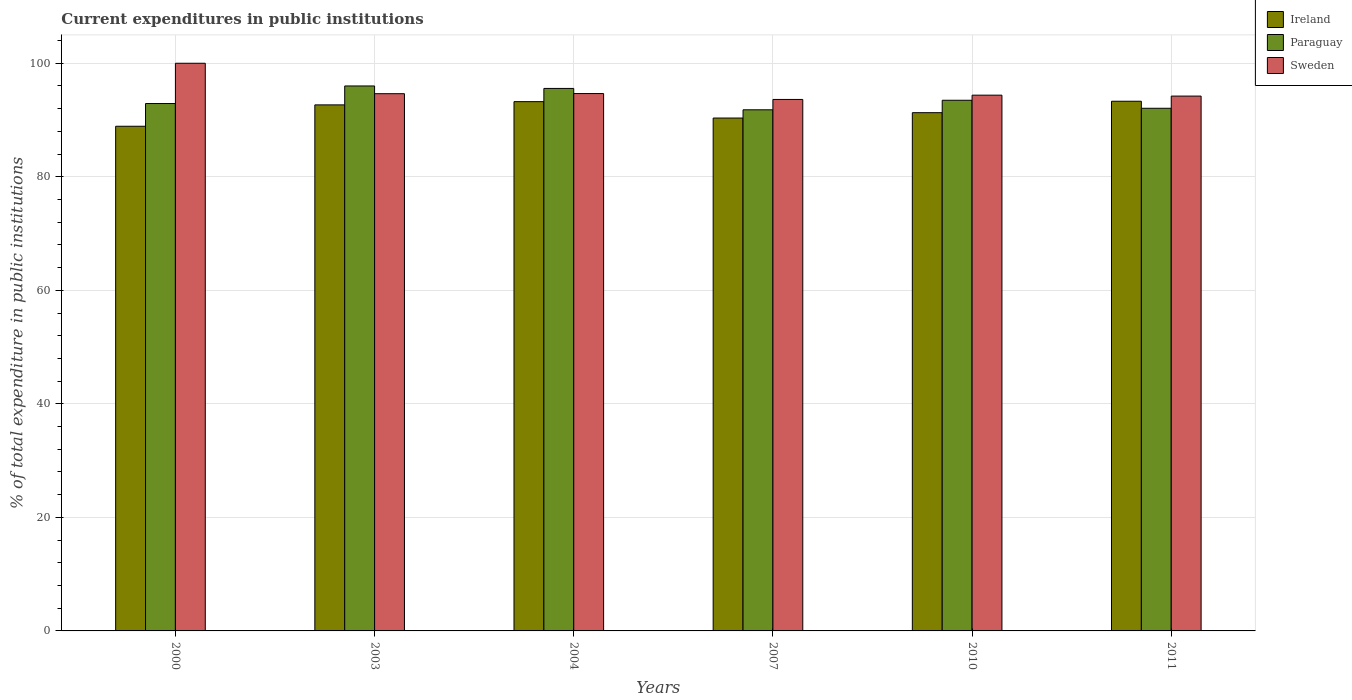Are the number of bars on each tick of the X-axis equal?
Provide a short and direct response. Yes. In how many cases, is the number of bars for a given year not equal to the number of legend labels?
Keep it short and to the point. 0. What is the current expenditures in public institutions in Paraguay in 2011?
Provide a succinct answer. 92.07. Across all years, what is the maximum current expenditures in public institutions in Paraguay?
Offer a terse response. 96. Across all years, what is the minimum current expenditures in public institutions in Sweden?
Give a very brief answer. 93.62. In which year was the current expenditures in public institutions in Sweden maximum?
Provide a short and direct response. 2000. What is the total current expenditures in public institutions in Paraguay in the graph?
Keep it short and to the point. 561.82. What is the difference between the current expenditures in public institutions in Paraguay in 2003 and that in 2011?
Give a very brief answer. 3.93. What is the difference between the current expenditures in public institutions in Ireland in 2007 and the current expenditures in public institutions in Sweden in 2004?
Make the answer very short. -4.31. What is the average current expenditures in public institutions in Ireland per year?
Keep it short and to the point. 91.63. In the year 2000, what is the difference between the current expenditures in public institutions in Sweden and current expenditures in public institutions in Ireland?
Make the answer very short. 11.1. In how many years, is the current expenditures in public institutions in Ireland greater than 56 %?
Give a very brief answer. 6. What is the ratio of the current expenditures in public institutions in Paraguay in 2004 to that in 2011?
Keep it short and to the point. 1.04. What is the difference between the highest and the second highest current expenditures in public institutions in Ireland?
Ensure brevity in your answer.  0.07. What is the difference between the highest and the lowest current expenditures in public institutions in Paraguay?
Offer a terse response. 4.2. In how many years, is the current expenditures in public institutions in Sweden greater than the average current expenditures in public institutions in Sweden taken over all years?
Provide a short and direct response. 1. Is the sum of the current expenditures in public institutions in Paraguay in 2000 and 2011 greater than the maximum current expenditures in public institutions in Ireland across all years?
Keep it short and to the point. Yes. What does the 3rd bar from the left in 2007 represents?
Your answer should be compact. Sweden. What does the 1st bar from the right in 2011 represents?
Your answer should be compact. Sweden. Is it the case that in every year, the sum of the current expenditures in public institutions in Ireland and current expenditures in public institutions in Sweden is greater than the current expenditures in public institutions in Paraguay?
Offer a terse response. Yes. Are all the bars in the graph horizontal?
Offer a terse response. No. How many years are there in the graph?
Your answer should be compact. 6. Does the graph contain any zero values?
Offer a terse response. No. Where does the legend appear in the graph?
Your answer should be compact. Top right. How are the legend labels stacked?
Ensure brevity in your answer.  Vertical. What is the title of the graph?
Provide a short and direct response. Current expenditures in public institutions. What is the label or title of the X-axis?
Give a very brief answer. Years. What is the label or title of the Y-axis?
Offer a terse response. % of total expenditure in public institutions. What is the % of total expenditure in public institutions in Ireland in 2000?
Your response must be concise. 88.9. What is the % of total expenditure in public institutions in Paraguay in 2000?
Offer a very short reply. 92.9. What is the % of total expenditure in public institutions in Ireland in 2003?
Ensure brevity in your answer.  92.67. What is the % of total expenditure in public institutions of Paraguay in 2003?
Offer a terse response. 96. What is the % of total expenditure in public institutions in Sweden in 2003?
Give a very brief answer. 94.64. What is the % of total expenditure in public institutions of Ireland in 2004?
Make the answer very short. 93.24. What is the % of total expenditure in public institutions in Paraguay in 2004?
Your answer should be very brief. 95.57. What is the % of total expenditure in public institutions of Sweden in 2004?
Your answer should be very brief. 94.66. What is the % of total expenditure in public institutions in Ireland in 2007?
Offer a terse response. 90.35. What is the % of total expenditure in public institutions of Paraguay in 2007?
Keep it short and to the point. 91.8. What is the % of total expenditure in public institutions of Sweden in 2007?
Make the answer very short. 93.62. What is the % of total expenditure in public institutions of Ireland in 2010?
Offer a very short reply. 91.29. What is the % of total expenditure in public institutions in Paraguay in 2010?
Make the answer very short. 93.48. What is the % of total expenditure in public institutions of Sweden in 2010?
Your response must be concise. 94.38. What is the % of total expenditure in public institutions in Ireland in 2011?
Offer a terse response. 93.31. What is the % of total expenditure in public institutions in Paraguay in 2011?
Keep it short and to the point. 92.07. What is the % of total expenditure in public institutions in Sweden in 2011?
Make the answer very short. 94.22. Across all years, what is the maximum % of total expenditure in public institutions of Ireland?
Offer a terse response. 93.31. Across all years, what is the maximum % of total expenditure in public institutions of Paraguay?
Offer a very short reply. 96. Across all years, what is the maximum % of total expenditure in public institutions in Sweden?
Provide a short and direct response. 100. Across all years, what is the minimum % of total expenditure in public institutions in Ireland?
Provide a succinct answer. 88.9. Across all years, what is the minimum % of total expenditure in public institutions of Paraguay?
Ensure brevity in your answer.  91.8. Across all years, what is the minimum % of total expenditure in public institutions in Sweden?
Offer a very short reply. 93.62. What is the total % of total expenditure in public institutions of Ireland in the graph?
Your answer should be very brief. 549.76. What is the total % of total expenditure in public institutions of Paraguay in the graph?
Keep it short and to the point. 561.83. What is the total % of total expenditure in public institutions of Sweden in the graph?
Your answer should be compact. 571.52. What is the difference between the % of total expenditure in public institutions in Ireland in 2000 and that in 2003?
Your response must be concise. -3.77. What is the difference between the % of total expenditure in public institutions in Paraguay in 2000 and that in 2003?
Offer a terse response. -3.1. What is the difference between the % of total expenditure in public institutions of Sweden in 2000 and that in 2003?
Keep it short and to the point. 5.36. What is the difference between the % of total expenditure in public institutions in Ireland in 2000 and that in 2004?
Provide a succinct answer. -4.33. What is the difference between the % of total expenditure in public institutions of Paraguay in 2000 and that in 2004?
Offer a terse response. -2.66. What is the difference between the % of total expenditure in public institutions in Sweden in 2000 and that in 2004?
Offer a terse response. 5.34. What is the difference between the % of total expenditure in public institutions in Ireland in 2000 and that in 2007?
Provide a succinct answer. -1.45. What is the difference between the % of total expenditure in public institutions in Paraguay in 2000 and that in 2007?
Give a very brief answer. 1.1. What is the difference between the % of total expenditure in public institutions in Sweden in 2000 and that in 2007?
Keep it short and to the point. 6.38. What is the difference between the % of total expenditure in public institutions of Ireland in 2000 and that in 2010?
Ensure brevity in your answer.  -2.39. What is the difference between the % of total expenditure in public institutions in Paraguay in 2000 and that in 2010?
Your response must be concise. -0.58. What is the difference between the % of total expenditure in public institutions in Sweden in 2000 and that in 2010?
Provide a short and direct response. 5.62. What is the difference between the % of total expenditure in public institutions of Ireland in 2000 and that in 2011?
Provide a short and direct response. -4.41. What is the difference between the % of total expenditure in public institutions in Paraguay in 2000 and that in 2011?
Provide a succinct answer. 0.83. What is the difference between the % of total expenditure in public institutions of Sweden in 2000 and that in 2011?
Make the answer very short. 5.78. What is the difference between the % of total expenditure in public institutions of Ireland in 2003 and that in 2004?
Offer a very short reply. -0.57. What is the difference between the % of total expenditure in public institutions in Paraguay in 2003 and that in 2004?
Ensure brevity in your answer.  0.44. What is the difference between the % of total expenditure in public institutions of Sweden in 2003 and that in 2004?
Your answer should be very brief. -0.02. What is the difference between the % of total expenditure in public institutions in Ireland in 2003 and that in 2007?
Your answer should be very brief. 2.32. What is the difference between the % of total expenditure in public institutions of Paraguay in 2003 and that in 2007?
Provide a short and direct response. 4.2. What is the difference between the % of total expenditure in public institutions in Sweden in 2003 and that in 2007?
Your answer should be compact. 1.02. What is the difference between the % of total expenditure in public institutions of Ireland in 2003 and that in 2010?
Your answer should be very brief. 1.37. What is the difference between the % of total expenditure in public institutions of Paraguay in 2003 and that in 2010?
Offer a terse response. 2.52. What is the difference between the % of total expenditure in public institutions in Sweden in 2003 and that in 2010?
Give a very brief answer. 0.26. What is the difference between the % of total expenditure in public institutions in Ireland in 2003 and that in 2011?
Your response must be concise. -0.64. What is the difference between the % of total expenditure in public institutions of Paraguay in 2003 and that in 2011?
Your response must be concise. 3.93. What is the difference between the % of total expenditure in public institutions in Sweden in 2003 and that in 2011?
Offer a very short reply. 0.42. What is the difference between the % of total expenditure in public institutions in Ireland in 2004 and that in 2007?
Make the answer very short. 2.89. What is the difference between the % of total expenditure in public institutions of Paraguay in 2004 and that in 2007?
Your answer should be compact. 3.76. What is the difference between the % of total expenditure in public institutions of Sweden in 2004 and that in 2007?
Your answer should be compact. 1.04. What is the difference between the % of total expenditure in public institutions of Ireland in 2004 and that in 2010?
Provide a succinct answer. 1.94. What is the difference between the % of total expenditure in public institutions in Paraguay in 2004 and that in 2010?
Provide a short and direct response. 2.08. What is the difference between the % of total expenditure in public institutions in Sweden in 2004 and that in 2010?
Your response must be concise. 0.28. What is the difference between the % of total expenditure in public institutions in Ireland in 2004 and that in 2011?
Keep it short and to the point. -0.07. What is the difference between the % of total expenditure in public institutions in Paraguay in 2004 and that in 2011?
Give a very brief answer. 3.49. What is the difference between the % of total expenditure in public institutions in Sweden in 2004 and that in 2011?
Your answer should be compact. 0.44. What is the difference between the % of total expenditure in public institutions in Ireland in 2007 and that in 2010?
Keep it short and to the point. -0.94. What is the difference between the % of total expenditure in public institutions of Paraguay in 2007 and that in 2010?
Make the answer very short. -1.68. What is the difference between the % of total expenditure in public institutions in Sweden in 2007 and that in 2010?
Your response must be concise. -0.76. What is the difference between the % of total expenditure in public institutions of Ireland in 2007 and that in 2011?
Provide a short and direct response. -2.96. What is the difference between the % of total expenditure in public institutions in Paraguay in 2007 and that in 2011?
Provide a succinct answer. -0.27. What is the difference between the % of total expenditure in public institutions of Sweden in 2007 and that in 2011?
Your response must be concise. -0.59. What is the difference between the % of total expenditure in public institutions in Ireland in 2010 and that in 2011?
Provide a short and direct response. -2.01. What is the difference between the % of total expenditure in public institutions in Paraguay in 2010 and that in 2011?
Your answer should be compact. 1.41. What is the difference between the % of total expenditure in public institutions in Sweden in 2010 and that in 2011?
Ensure brevity in your answer.  0.16. What is the difference between the % of total expenditure in public institutions in Ireland in 2000 and the % of total expenditure in public institutions in Paraguay in 2003?
Ensure brevity in your answer.  -7.1. What is the difference between the % of total expenditure in public institutions in Ireland in 2000 and the % of total expenditure in public institutions in Sweden in 2003?
Provide a succinct answer. -5.74. What is the difference between the % of total expenditure in public institutions in Paraguay in 2000 and the % of total expenditure in public institutions in Sweden in 2003?
Make the answer very short. -1.73. What is the difference between the % of total expenditure in public institutions in Ireland in 2000 and the % of total expenditure in public institutions in Paraguay in 2004?
Provide a short and direct response. -6.66. What is the difference between the % of total expenditure in public institutions of Ireland in 2000 and the % of total expenditure in public institutions of Sweden in 2004?
Your response must be concise. -5.76. What is the difference between the % of total expenditure in public institutions in Paraguay in 2000 and the % of total expenditure in public institutions in Sweden in 2004?
Your answer should be very brief. -1.76. What is the difference between the % of total expenditure in public institutions in Ireland in 2000 and the % of total expenditure in public institutions in Paraguay in 2007?
Provide a succinct answer. -2.9. What is the difference between the % of total expenditure in public institutions of Ireland in 2000 and the % of total expenditure in public institutions of Sweden in 2007?
Provide a short and direct response. -4.72. What is the difference between the % of total expenditure in public institutions in Paraguay in 2000 and the % of total expenditure in public institutions in Sweden in 2007?
Your response must be concise. -0.72. What is the difference between the % of total expenditure in public institutions in Ireland in 2000 and the % of total expenditure in public institutions in Paraguay in 2010?
Your response must be concise. -4.58. What is the difference between the % of total expenditure in public institutions in Ireland in 2000 and the % of total expenditure in public institutions in Sweden in 2010?
Your answer should be very brief. -5.48. What is the difference between the % of total expenditure in public institutions of Paraguay in 2000 and the % of total expenditure in public institutions of Sweden in 2010?
Your answer should be very brief. -1.47. What is the difference between the % of total expenditure in public institutions in Ireland in 2000 and the % of total expenditure in public institutions in Paraguay in 2011?
Provide a short and direct response. -3.17. What is the difference between the % of total expenditure in public institutions in Ireland in 2000 and the % of total expenditure in public institutions in Sweden in 2011?
Provide a short and direct response. -5.32. What is the difference between the % of total expenditure in public institutions in Paraguay in 2000 and the % of total expenditure in public institutions in Sweden in 2011?
Give a very brief answer. -1.31. What is the difference between the % of total expenditure in public institutions of Ireland in 2003 and the % of total expenditure in public institutions of Paraguay in 2004?
Offer a very short reply. -2.9. What is the difference between the % of total expenditure in public institutions of Ireland in 2003 and the % of total expenditure in public institutions of Sweden in 2004?
Ensure brevity in your answer.  -2. What is the difference between the % of total expenditure in public institutions in Paraguay in 2003 and the % of total expenditure in public institutions in Sweden in 2004?
Your answer should be very brief. 1.34. What is the difference between the % of total expenditure in public institutions in Ireland in 2003 and the % of total expenditure in public institutions in Paraguay in 2007?
Give a very brief answer. 0.87. What is the difference between the % of total expenditure in public institutions in Ireland in 2003 and the % of total expenditure in public institutions in Sweden in 2007?
Offer a very short reply. -0.96. What is the difference between the % of total expenditure in public institutions of Paraguay in 2003 and the % of total expenditure in public institutions of Sweden in 2007?
Your answer should be compact. 2.38. What is the difference between the % of total expenditure in public institutions in Ireland in 2003 and the % of total expenditure in public institutions in Paraguay in 2010?
Provide a short and direct response. -0.82. What is the difference between the % of total expenditure in public institutions in Ireland in 2003 and the % of total expenditure in public institutions in Sweden in 2010?
Ensure brevity in your answer.  -1.71. What is the difference between the % of total expenditure in public institutions of Paraguay in 2003 and the % of total expenditure in public institutions of Sweden in 2010?
Give a very brief answer. 1.62. What is the difference between the % of total expenditure in public institutions in Ireland in 2003 and the % of total expenditure in public institutions in Paraguay in 2011?
Offer a terse response. 0.6. What is the difference between the % of total expenditure in public institutions in Ireland in 2003 and the % of total expenditure in public institutions in Sweden in 2011?
Make the answer very short. -1.55. What is the difference between the % of total expenditure in public institutions in Paraguay in 2003 and the % of total expenditure in public institutions in Sweden in 2011?
Provide a succinct answer. 1.78. What is the difference between the % of total expenditure in public institutions of Ireland in 2004 and the % of total expenditure in public institutions of Paraguay in 2007?
Give a very brief answer. 1.44. What is the difference between the % of total expenditure in public institutions of Ireland in 2004 and the % of total expenditure in public institutions of Sweden in 2007?
Offer a terse response. -0.39. What is the difference between the % of total expenditure in public institutions in Paraguay in 2004 and the % of total expenditure in public institutions in Sweden in 2007?
Make the answer very short. 1.94. What is the difference between the % of total expenditure in public institutions in Ireland in 2004 and the % of total expenditure in public institutions in Paraguay in 2010?
Make the answer very short. -0.25. What is the difference between the % of total expenditure in public institutions of Ireland in 2004 and the % of total expenditure in public institutions of Sweden in 2010?
Your response must be concise. -1.14. What is the difference between the % of total expenditure in public institutions in Paraguay in 2004 and the % of total expenditure in public institutions in Sweden in 2010?
Provide a succinct answer. 1.19. What is the difference between the % of total expenditure in public institutions of Ireland in 2004 and the % of total expenditure in public institutions of Paraguay in 2011?
Your answer should be very brief. 1.17. What is the difference between the % of total expenditure in public institutions in Ireland in 2004 and the % of total expenditure in public institutions in Sweden in 2011?
Your answer should be very brief. -0.98. What is the difference between the % of total expenditure in public institutions in Paraguay in 2004 and the % of total expenditure in public institutions in Sweden in 2011?
Your response must be concise. 1.35. What is the difference between the % of total expenditure in public institutions of Ireland in 2007 and the % of total expenditure in public institutions of Paraguay in 2010?
Make the answer very short. -3.13. What is the difference between the % of total expenditure in public institutions in Ireland in 2007 and the % of total expenditure in public institutions in Sweden in 2010?
Ensure brevity in your answer.  -4.03. What is the difference between the % of total expenditure in public institutions in Paraguay in 2007 and the % of total expenditure in public institutions in Sweden in 2010?
Ensure brevity in your answer.  -2.58. What is the difference between the % of total expenditure in public institutions of Ireland in 2007 and the % of total expenditure in public institutions of Paraguay in 2011?
Provide a short and direct response. -1.72. What is the difference between the % of total expenditure in public institutions in Ireland in 2007 and the % of total expenditure in public institutions in Sweden in 2011?
Provide a succinct answer. -3.87. What is the difference between the % of total expenditure in public institutions in Paraguay in 2007 and the % of total expenditure in public institutions in Sweden in 2011?
Your response must be concise. -2.42. What is the difference between the % of total expenditure in public institutions in Ireland in 2010 and the % of total expenditure in public institutions in Paraguay in 2011?
Offer a terse response. -0.78. What is the difference between the % of total expenditure in public institutions in Ireland in 2010 and the % of total expenditure in public institutions in Sweden in 2011?
Your response must be concise. -2.92. What is the difference between the % of total expenditure in public institutions in Paraguay in 2010 and the % of total expenditure in public institutions in Sweden in 2011?
Give a very brief answer. -0.73. What is the average % of total expenditure in public institutions of Ireland per year?
Make the answer very short. 91.63. What is the average % of total expenditure in public institutions of Paraguay per year?
Ensure brevity in your answer.  93.64. What is the average % of total expenditure in public institutions in Sweden per year?
Your answer should be compact. 95.25. In the year 2000, what is the difference between the % of total expenditure in public institutions in Ireland and % of total expenditure in public institutions in Paraguay?
Provide a succinct answer. -4. In the year 2000, what is the difference between the % of total expenditure in public institutions in Ireland and % of total expenditure in public institutions in Sweden?
Keep it short and to the point. -11.1. In the year 2000, what is the difference between the % of total expenditure in public institutions of Paraguay and % of total expenditure in public institutions of Sweden?
Keep it short and to the point. -7.1. In the year 2003, what is the difference between the % of total expenditure in public institutions of Ireland and % of total expenditure in public institutions of Paraguay?
Provide a short and direct response. -3.33. In the year 2003, what is the difference between the % of total expenditure in public institutions of Ireland and % of total expenditure in public institutions of Sweden?
Your answer should be compact. -1.97. In the year 2003, what is the difference between the % of total expenditure in public institutions of Paraguay and % of total expenditure in public institutions of Sweden?
Offer a very short reply. 1.36. In the year 2004, what is the difference between the % of total expenditure in public institutions in Ireland and % of total expenditure in public institutions in Paraguay?
Your response must be concise. -2.33. In the year 2004, what is the difference between the % of total expenditure in public institutions in Ireland and % of total expenditure in public institutions in Sweden?
Offer a terse response. -1.43. In the year 2004, what is the difference between the % of total expenditure in public institutions of Paraguay and % of total expenditure in public institutions of Sweden?
Provide a short and direct response. 0.9. In the year 2007, what is the difference between the % of total expenditure in public institutions of Ireland and % of total expenditure in public institutions of Paraguay?
Offer a terse response. -1.45. In the year 2007, what is the difference between the % of total expenditure in public institutions in Ireland and % of total expenditure in public institutions in Sweden?
Ensure brevity in your answer.  -3.27. In the year 2007, what is the difference between the % of total expenditure in public institutions in Paraguay and % of total expenditure in public institutions in Sweden?
Your answer should be very brief. -1.82. In the year 2010, what is the difference between the % of total expenditure in public institutions in Ireland and % of total expenditure in public institutions in Paraguay?
Provide a succinct answer. -2.19. In the year 2010, what is the difference between the % of total expenditure in public institutions in Ireland and % of total expenditure in public institutions in Sweden?
Keep it short and to the point. -3.09. In the year 2010, what is the difference between the % of total expenditure in public institutions of Paraguay and % of total expenditure in public institutions of Sweden?
Your answer should be compact. -0.9. In the year 2011, what is the difference between the % of total expenditure in public institutions in Ireland and % of total expenditure in public institutions in Paraguay?
Your answer should be compact. 1.24. In the year 2011, what is the difference between the % of total expenditure in public institutions in Ireland and % of total expenditure in public institutions in Sweden?
Your answer should be compact. -0.91. In the year 2011, what is the difference between the % of total expenditure in public institutions in Paraguay and % of total expenditure in public institutions in Sweden?
Make the answer very short. -2.15. What is the ratio of the % of total expenditure in public institutions of Ireland in 2000 to that in 2003?
Offer a terse response. 0.96. What is the ratio of the % of total expenditure in public institutions in Paraguay in 2000 to that in 2003?
Your answer should be compact. 0.97. What is the ratio of the % of total expenditure in public institutions in Sweden in 2000 to that in 2003?
Offer a terse response. 1.06. What is the ratio of the % of total expenditure in public institutions of Ireland in 2000 to that in 2004?
Give a very brief answer. 0.95. What is the ratio of the % of total expenditure in public institutions in Paraguay in 2000 to that in 2004?
Offer a very short reply. 0.97. What is the ratio of the % of total expenditure in public institutions of Sweden in 2000 to that in 2004?
Give a very brief answer. 1.06. What is the ratio of the % of total expenditure in public institutions of Paraguay in 2000 to that in 2007?
Ensure brevity in your answer.  1.01. What is the ratio of the % of total expenditure in public institutions in Sweden in 2000 to that in 2007?
Offer a terse response. 1.07. What is the ratio of the % of total expenditure in public institutions in Ireland in 2000 to that in 2010?
Offer a very short reply. 0.97. What is the ratio of the % of total expenditure in public institutions of Sweden in 2000 to that in 2010?
Ensure brevity in your answer.  1.06. What is the ratio of the % of total expenditure in public institutions in Ireland in 2000 to that in 2011?
Provide a short and direct response. 0.95. What is the ratio of the % of total expenditure in public institutions of Paraguay in 2000 to that in 2011?
Your answer should be compact. 1.01. What is the ratio of the % of total expenditure in public institutions of Sweden in 2000 to that in 2011?
Ensure brevity in your answer.  1.06. What is the ratio of the % of total expenditure in public institutions of Ireland in 2003 to that in 2007?
Offer a terse response. 1.03. What is the ratio of the % of total expenditure in public institutions in Paraguay in 2003 to that in 2007?
Ensure brevity in your answer.  1.05. What is the ratio of the % of total expenditure in public institutions in Sweden in 2003 to that in 2007?
Your response must be concise. 1.01. What is the ratio of the % of total expenditure in public institutions of Paraguay in 2003 to that in 2010?
Keep it short and to the point. 1.03. What is the ratio of the % of total expenditure in public institutions of Paraguay in 2003 to that in 2011?
Give a very brief answer. 1.04. What is the ratio of the % of total expenditure in public institutions of Sweden in 2003 to that in 2011?
Keep it short and to the point. 1. What is the ratio of the % of total expenditure in public institutions in Ireland in 2004 to that in 2007?
Provide a succinct answer. 1.03. What is the ratio of the % of total expenditure in public institutions of Paraguay in 2004 to that in 2007?
Your response must be concise. 1.04. What is the ratio of the % of total expenditure in public institutions in Sweden in 2004 to that in 2007?
Provide a short and direct response. 1.01. What is the ratio of the % of total expenditure in public institutions of Ireland in 2004 to that in 2010?
Your response must be concise. 1.02. What is the ratio of the % of total expenditure in public institutions of Paraguay in 2004 to that in 2010?
Keep it short and to the point. 1.02. What is the ratio of the % of total expenditure in public institutions of Sweden in 2004 to that in 2010?
Your answer should be very brief. 1. What is the ratio of the % of total expenditure in public institutions in Paraguay in 2004 to that in 2011?
Offer a terse response. 1.04. What is the ratio of the % of total expenditure in public institutions in Sweden in 2004 to that in 2011?
Offer a very short reply. 1. What is the ratio of the % of total expenditure in public institutions of Sweden in 2007 to that in 2010?
Provide a succinct answer. 0.99. What is the ratio of the % of total expenditure in public institutions in Ireland in 2007 to that in 2011?
Offer a terse response. 0.97. What is the ratio of the % of total expenditure in public institutions in Ireland in 2010 to that in 2011?
Provide a short and direct response. 0.98. What is the ratio of the % of total expenditure in public institutions in Paraguay in 2010 to that in 2011?
Give a very brief answer. 1.02. What is the difference between the highest and the second highest % of total expenditure in public institutions of Ireland?
Your answer should be compact. 0.07. What is the difference between the highest and the second highest % of total expenditure in public institutions of Paraguay?
Make the answer very short. 0.44. What is the difference between the highest and the second highest % of total expenditure in public institutions in Sweden?
Offer a very short reply. 5.34. What is the difference between the highest and the lowest % of total expenditure in public institutions of Ireland?
Your answer should be very brief. 4.41. What is the difference between the highest and the lowest % of total expenditure in public institutions of Paraguay?
Keep it short and to the point. 4.2. What is the difference between the highest and the lowest % of total expenditure in public institutions of Sweden?
Provide a short and direct response. 6.38. 